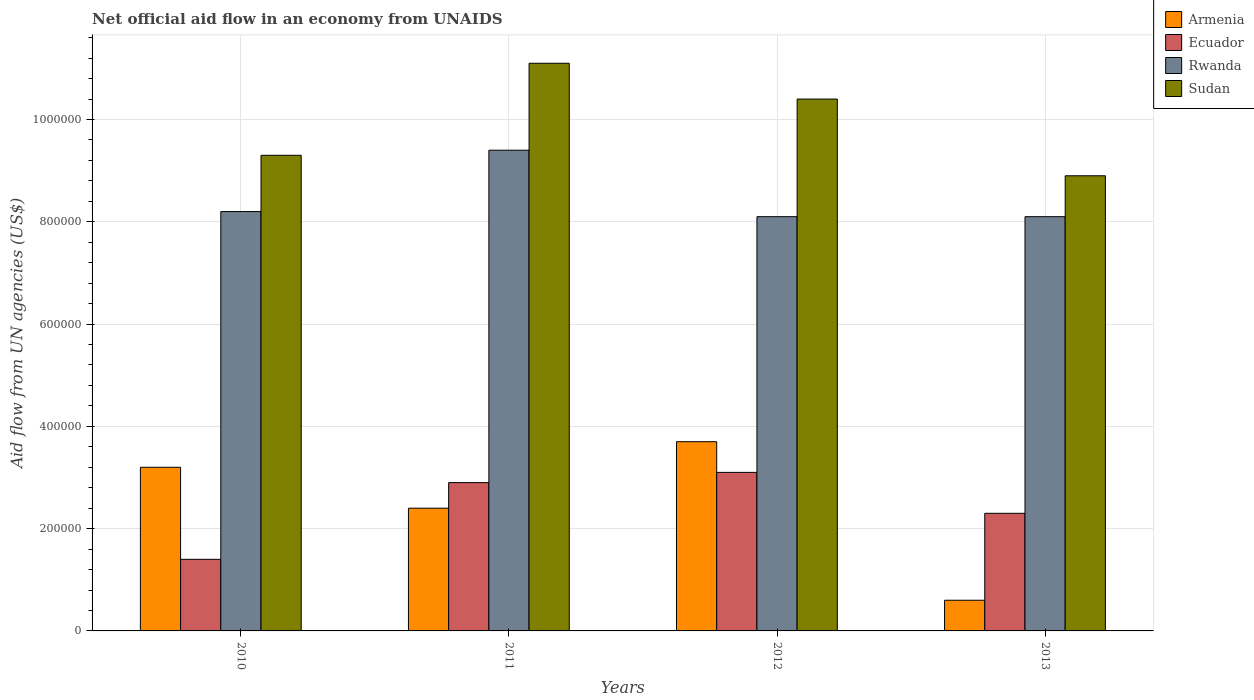Are the number of bars on each tick of the X-axis equal?
Provide a succinct answer. Yes. How many bars are there on the 1st tick from the left?
Your answer should be very brief. 4. How many bars are there on the 2nd tick from the right?
Provide a short and direct response. 4. In how many cases, is the number of bars for a given year not equal to the number of legend labels?
Give a very brief answer. 0. What is the net official aid flow in Sudan in 2012?
Offer a terse response. 1.04e+06. Across all years, what is the minimum net official aid flow in Rwanda?
Ensure brevity in your answer.  8.10e+05. In which year was the net official aid flow in Ecuador maximum?
Keep it short and to the point. 2012. What is the total net official aid flow in Ecuador in the graph?
Provide a succinct answer. 9.70e+05. What is the difference between the net official aid flow in Armenia in 2012 and that in 2013?
Keep it short and to the point. 3.10e+05. What is the average net official aid flow in Ecuador per year?
Offer a terse response. 2.42e+05. In the year 2010, what is the difference between the net official aid flow in Ecuador and net official aid flow in Rwanda?
Your answer should be compact. -6.80e+05. In how many years, is the net official aid flow in Armenia greater than 520000 US$?
Make the answer very short. 0. What is the ratio of the net official aid flow in Armenia in 2010 to that in 2011?
Your response must be concise. 1.33. Is the net official aid flow in Armenia in 2011 less than that in 2013?
Provide a succinct answer. No. Is the difference between the net official aid flow in Ecuador in 2011 and 2013 greater than the difference between the net official aid flow in Rwanda in 2011 and 2013?
Your response must be concise. No. What is the difference between the highest and the second highest net official aid flow in Rwanda?
Your response must be concise. 1.20e+05. What is the difference between the highest and the lowest net official aid flow in Armenia?
Keep it short and to the point. 3.10e+05. Is the sum of the net official aid flow in Rwanda in 2010 and 2011 greater than the maximum net official aid flow in Ecuador across all years?
Keep it short and to the point. Yes. Is it the case that in every year, the sum of the net official aid flow in Armenia and net official aid flow in Ecuador is greater than the sum of net official aid flow in Rwanda and net official aid flow in Sudan?
Provide a short and direct response. No. What does the 4th bar from the left in 2010 represents?
Your response must be concise. Sudan. What does the 1st bar from the right in 2013 represents?
Offer a very short reply. Sudan. Is it the case that in every year, the sum of the net official aid flow in Armenia and net official aid flow in Ecuador is greater than the net official aid flow in Sudan?
Ensure brevity in your answer.  No. Are the values on the major ticks of Y-axis written in scientific E-notation?
Provide a short and direct response. No. Does the graph contain any zero values?
Keep it short and to the point. No. Does the graph contain grids?
Offer a terse response. Yes. How many legend labels are there?
Your answer should be very brief. 4. How are the legend labels stacked?
Give a very brief answer. Vertical. What is the title of the graph?
Your answer should be very brief. Net official aid flow in an economy from UNAIDS. What is the label or title of the Y-axis?
Your answer should be very brief. Aid flow from UN agencies (US$). What is the Aid flow from UN agencies (US$) of Armenia in 2010?
Keep it short and to the point. 3.20e+05. What is the Aid flow from UN agencies (US$) in Rwanda in 2010?
Ensure brevity in your answer.  8.20e+05. What is the Aid flow from UN agencies (US$) of Sudan in 2010?
Offer a very short reply. 9.30e+05. What is the Aid flow from UN agencies (US$) of Ecuador in 2011?
Keep it short and to the point. 2.90e+05. What is the Aid flow from UN agencies (US$) in Rwanda in 2011?
Your answer should be compact. 9.40e+05. What is the Aid flow from UN agencies (US$) of Sudan in 2011?
Provide a short and direct response. 1.11e+06. What is the Aid flow from UN agencies (US$) of Armenia in 2012?
Keep it short and to the point. 3.70e+05. What is the Aid flow from UN agencies (US$) in Rwanda in 2012?
Make the answer very short. 8.10e+05. What is the Aid flow from UN agencies (US$) of Sudan in 2012?
Your answer should be compact. 1.04e+06. What is the Aid flow from UN agencies (US$) in Rwanda in 2013?
Your response must be concise. 8.10e+05. What is the Aid flow from UN agencies (US$) of Sudan in 2013?
Make the answer very short. 8.90e+05. Across all years, what is the maximum Aid flow from UN agencies (US$) of Ecuador?
Make the answer very short. 3.10e+05. Across all years, what is the maximum Aid flow from UN agencies (US$) in Rwanda?
Keep it short and to the point. 9.40e+05. Across all years, what is the maximum Aid flow from UN agencies (US$) in Sudan?
Make the answer very short. 1.11e+06. Across all years, what is the minimum Aid flow from UN agencies (US$) of Armenia?
Keep it short and to the point. 6.00e+04. Across all years, what is the minimum Aid flow from UN agencies (US$) in Rwanda?
Your response must be concise. 8.10e+05. Across all years, what is the minimum Aid flow from UN agencies (US$) of Sudan?
Offer a very short reply. 8.90e+05. What is the total Aid flow from UN agencies (US$) in Armenia in the graph?
Offer a terse response. 9.90e+05. What is the total Aid flow from UN agencies (US$) of Ecuador in the graph?
Provide a short and direct response. 9.70e+05. What is the total Aid flow from UN agencies (US$) of Rwanda in the graph?
Offer a terse response. 3.38e+06. What is the total Aid flow from UN agencies (US$) of Sudan in the graph?
Provide a succinct answer. 3.97e+06. What is the difference between the Aid flow from UN agencies (US$) in Armenia in 2010 and that in 2011?
Your answer should be compact. 8.00e+04. What is the difference between the Aid flow from UN agencies (US$) of Rwanda in 2010 and that in 2011?
Offer a terse response. -1.20e+05. What is the difference between the Aid flow from UN agencies (US$) of Armenia in 2010 and that in 2012?
Your answer should be very brief. -5.00e+04. What is the difference between the Aid flow from UN agencies (US$) in Sudan in 2010 and that in 2012?
Your answer should be very brief. -1.10e+05. What is the difference between the Aid flow from UN agencies (US$) in Ecuador in 2010 and that in 2013?
Give a very brief answer. -9.00e+04. What is the difference between the Aid flow from UN agencies (US$) of Rwanda in 2010 and that in 2013?
Give a very brief answer. 10000. What is the difference between the Aid flow from UN agencies (US$) in Sudan in 2010 and that in 2013?
Your answer should be very brief. 4.00e+04. What is the difference between the Aid flow from UN agencies (US$) of Armenia in 2011 and that in 2012?
Make the answer very short. -1.30e+05. What is the difference between the Aid flow from UN agencies (US$) of Sudan in 2011 and that in 2012?
Give a very brief answer. 7.00e+04. What is the difference between the Aid flow from UN agencies (US$) in Ecuador in 2011 and that in 2013?
Your answer should be compact. 6.00e+04. What is the difference between the Aid flow from UN agencies (US$) in Sudan in 2011 and that in 2013?
Offer a very short reply. 2.20e+05. What is the difference between the Aid flow from UN agencies (US$) of Armenia in 2010 and the Aid flow from UN agencies (US$) of Ecuador in 2011?
Make the answer very short. 3.00e+04. What is the difference between the Aid flow from UN agencies (US$) in Armenia in 2010 and the Aid flow from UN agencies (US$) in Rwanda in 2011?
Provide a succinct answer. -6.20e+05. What is the difference between the Aid flow from UN agencies (US$) in Armenia in 2010 and the Aid flow from UN agencies (US$) in Sudan in 2011?
Ensure brevity in your answer.  -7.90e+05. What is the difference between the Aid flow from UN agencies (US$) of Ecuador in 2010 and the Aid flow from UN agencies (US$) of Rwanda in 2011?
Offer a terse response. -8.00e+05. What is the difference between the Aid flow from UN agencies (US$) of Ecuador in 2010 and the Aid flow from UN agencies (US$) of Sudan in 2011?
Keep it short and to the point. -9.70e+05. What is the difference between the Aid flow from UN agencies (US$) in Armenia in 2010 and the Aid flow from UN agencies (US$) in Ecuador in 2012?
Provide a succinct answer. 10000. What is the difference between the Aid flow from UN agencies (US$) of Armenia in 2010 and the Aid flow from UN agencies (US$) of Rwanda in 2012?
Provide a short and direct response. -4.90e+05. What is the difference between the Aid flow from UN agencies (US$) of Armenia in 2010 and the Aid flow from UN agencies (US$) of Sudan in 2012?
Your answer should be compact. -7.20e+05. What is the difference between the Aid flow from UN agencies (US$) of Ecuador in 2010 and the Aid flow from UN agencies (US$) of Rwanda in 2012?
Your response must be concise. -6.70e+05. What is the difference between the Aid flow from UN agencies (US$) in Ecuador in 2010 and the Aid flow from UN agencies (US$) in Sudan in 2012?
Your response must be concise. -9.00e+05. What is the difference between the Aid flow from UN agencies (US$) of Rwanda in 2010 and the Aid flow from UN agencies (US$) of Sudan in 2012?
Keep it short and to the point. -2.20e+05. What is the difference between the Aid flow from UN agencies (US$) of Armenia in 2010 and the Aid flow from UN agencies (US$) of Ecuador in 2013?
Provide a succinct answer. 9.00e+04. What is the difference between the Aid flow from UN agencies (US$) of Armenia in 2010 and the Aid flow from UN agencies (US$) of Rwanda in 2013?
Your response must be concise. -4.90e+05. What is the difference between the Aid flow from UN agencies (US$) of Armenia in 2010 and the Aid flow from UN agencies (US$) of Sudan in 2013?
Keep it short and to the point. -5.70e+05. What is the difference between the Aid flow from UN agencies (US$) in Ecuador in 2010 and the Aid flow from UN agencies (US$) in Rwanda in 2013?
Provide a succinct answer. -6.70e+05. What is the difference between the Aid flow from UN agencies (US$) in Ecuador in 2010 and the Aid flow from UN agencies (US$) in Sudan in 2013?
Your answer should be very brief. -7.50e+05. What is the difference between the Aid flow from UN agencies (US$) in Armenia in 2011 and the Aid flow from UN agencies (US$) in Rwanda in 2012?
Your answer should be compact. -5.70e+05. What is the difference between the Aid flow from UN agencies (US$) in Armenia in 2011 and the Aid flow from UN agencies (US$) in Sudan in 2012?
Ensure brevity in your answer.  -8.00e+05. What is the difference between the Aid flow from UN agencies (US$) of Ecuador in 2011 and the Aid flow from UN agencies (US$) of Rwanda in 2012?
Give a very brief answer. -5.20e+05. What is the difference between the Aid flow from UN agencies (US$) in Ecuador in 2011 and the Aid flow from UN agencies (US$) in Sudan in 2012?
Keep it short and to the point. -7.50e+05. What is the difference between the Aid flow from UN agencies (US$) in Armenia in 2011 and the Aid flow from UN agencies (US$) in Rwanda in 2013?
Provide a short and direct response. -5.70e+05. What is the difference between the Aid flow from UN agencies (US$) of Armenia in 2011 and the Aid flow from UN agencies (US$) of Sudan in 2013?
Ensure brevity in your answer.  -6.50e+05. What is the difference between the Aid flow from UN agencies (US$) in Ecuador in 2011 and the Aid flow from UN agencies (US$) in Rwanda in 2013?
Your response must be concise. -5.20e+05. What is the difference between the Aid flow from UN agencies (US$) in Ecuador in 2011 and the Aid flow from UN agencies (US$) in Sudan in 2013?
Ensure brevity in your answer.  -6.00e+05. What is the difference between the Aid flow from UN agencies (US$) of Armenia in 2012 and the Aid flow from UN agencies (US$) of Rwanda in 2013?
Make the answer very short. -4.40e+05. What is the difference between the Aid flow from UN agencies (US$) in Armenia in 2012 and the Aid flow from UN agencies (US$) in Sudan in 2013?
Your answer should be compact. -5.20e+05. What is the difference between the Aid flow from UN agencies (US$) in Ecuador in 2012 and the Aid flow from UN agencies (US$) in Rwanda in 2013?
Your answer should be compact. -5.00e+05. What is the difference between the Aid flow from UN agencies (US$) of Ecuador in 2012 and the Aid flow from UN agencies (US$) of Sudan in 2013?
Your response must be concise. -5.80e+05. What is the average Aid flow from UN agencies (US$) in Armenia per year?
Provide a succinct answer. 2.48e+05. What is the average Aid flow from UN agencies (US$) in Ecuador per year?
Offer a terse response. 2.42e+05. What is the average Aid flow from UN agencies (US$) in Rwanda per year?
Provide a succinct answer. 8.45e+05. What is the average Aid flow from UN agencies (US$) in Sudan per year?
Your answer should be compact. 9.92e+05. In the year 2010, what is the difference between the Aid flow from UN agencies (US$) of Armenia and Aid flow from UN agencies (US$) of Rwanda?
Your answer should be very brief. -5.00e+05. In the year 2010, what is the difference between the Aid flow from UN agencies (US$) of Armenia and Aid flow from UN agencies (US$) of Sudan?
Your answer should be compact. -6.10e+05. In the year 2010, what is the difference between the Aid flow from UN agencies (US$) of Ecuador and Aid flow from UN agencies (US$) of Rwanda?
Your answer should be very brief. -6.80e+05. In the year 2010, what is the difference between the Aid flow from UN agencies (US$) of Ecuador and Aid flow from UN agencies (US$) of Sudan?
Offer a very short reply. -7.90e+05. In the year 2010, what is the difference between the Aid flow from UN agencies (US$) in Rwanda and Aid flow from UN agencies (US$) in Sudan?
Provide a short and direct response. -1.10e+05. In the year 2011, what is the difference between the Aid flow from UN agencies (US$) of Armenia and Aid flow from UN agencies (US$) of Ecuador?
Your response must be concise. -5.00e+04. In the year 2011, what is the difference between the Aid flow from UN agencies (US$) of Armenia and Aid flow from UN agencies (US$) of Rwanda?
Provide a short and direct response. -7.00e+05. In the year 2011, what is the difference between the Aid flow from UN agencies (US$) of Armenia and Aid flow from UN agencies (US$) of Sudan?
Provide a short and direct response. -8.70e+05. In the year 2011, what is the difference between the Aid flow from UN agencies (US$) in Ecuador and Aid flow from UN agencies (US$) in Rwanda?
Provide a succinct answer. -6.50e+05. In the year 2011, what is the difference between the Aid flow from UN agencies (US$) of Ecuador and Aid flow from UN agencies (US$) of Sudan?
Your answer should be very brief. -8.20e+05. In the year 2012, what is the difference between the Aid flow from UN agencies (US$) of Armenia and Aid flow from UN agencies (US$) of Ecuador?
Provide a succinct answer. 6.00e+04. In the year 2012, what is the difference between the Aid flow from UN agencies (US$) of Armenia and Aid flow from UN agencies (US$) of Rwanda?
Ensure brevity in your answer.  -4.40e+05. In the year 2012, what is the difference between the Aid flow from UN agencies (US$) of Armenia and Aid flow from UN agencies (US$) of Sudan?
Offer a very short reply. -6.70e+05. In the year 2012, what is the difference between the Aid flow from UN agencies (US$) of Ecuador and Aid flow from UN agencies (US$) of Rwanda?
Keep it short and to the point. -5.00e+05. In the year 2012, what is the difference between the Aid flow from UN agencies (US$) of Ecuador and Aid flow from UN agencies (US$) of Sudan?
Ensure brevity in your answer.  -7.30e+05. In the year 2013, what is the difference between the Aid flow from UN agencies (US$) of Armenia and Aid flow from UN agencies (US$) of Ecuador?
Make the answer very short. -1.70e+05. In the year 2013, what is the difference between the Aid flow from UN agencies (US$) of Armenia and Aid flow from UN agencies (US$) of Rwanda?
Offer a very short reply. -7.50e+05. In the year 2013, what is the difference between the Aid flow from UN agencies (US$) of Armenia and Aid flow from UN agencies (US$) of Sudan?
Ensure brevity in your answer.  -8.30e+05. In the year 2013, what is the difference between the Aid flow from UN agencies (US$) in Ecuador and Aid flow from UN agencies (US$) in Rwanda?
Your answer should be compact. -5.80e+05. In the year 2013, what is the difference between the Aid flow from UN agencies (US$) of Ecuador and Aid flow from UN agencies (US$) of Sudan?
Provide a succinct answer. -6.60e+05. In the year 2013, what is the difference between the Aid flow from UN agencies (US$) in Rwanda and Aid flow from UN agencies (US$) in Sudan?
Make the answer very short. -8.00e+04. What is the ratio of the Aid flow from UN agencies (US$) of Ecuador in 2010 to that in 2011?
Offer a terse response. 0.48. What is the ratio of the Aid flow from UN agencies (US$) in Rwanda in 2010 to that in 2011?
Your answer should be compact. 0.87. What is the ratio of the Aid flow from UN agencies (US$) of Sudan in 2010 to that in 2011?
Your answer should be compact. 0.84. What is the ratio of the Aid flow from UN agencies (US$) of Armenia in 2010 to that in 2012?
Provide a succinct answer. 0.86. What is the ratio of the Aid flow from UN agencies (US$) in Ecuador in 2010 to that in 2012?
Your answer should be very brief. 0.45. What is the ratio of the Aid flow from UN agencies (US$) of Rwanda in 2010 to that in 2012?
Your answer should be very brief. 1.01. What is the ratio of the Aid flow from UN agencies (US$) of Sudan in 2010 to that in 2012?
Give a very brief answer. 0.89. What is the ratio of the Aid flow from UN agencies (US$) in Armenia in 2010 to that in 2013?
Make the answer very short. 5.33. What is the ratio of the Aid flow from UN agencies (US$) in Ecuador in 2010 to that in 2013?
Provide a short and direct response. 0.61. What is the ratio of the Aid flow from UN agencies (US$) in Rwanda in 2010 to that in 2013?
Offer a terse response. 1.01. What is the ratio of the Aid flow from UN agencies (US$) in Sudan in 2010 to that in 2013?
Your answer should be very brief. 1.04. What is the ratio of the Aid flow from UN agencies (US$) of Armenia in 2011 to that in 2012?
Give a very brief answer. 0.65. What is the ratio of the Aid flow from UN agencies (US$) in Ecuador in 2011 to that in 2012?
Offer a terse response. 0.94. What is the ratio of the Aid flow from UN agencies (US$) in Rwanda in 2011 to that in 2012?
Offer a very short reply. 1.16. What is the ratio of the Aid flow from UN agencies (US$) in Sudan in 2011 to that in 2012?
Your answer should be very brief. 1.07. What is the ratio of the Aid flow from UN agencies (US$) in Armenia in 2011 to that in 2013?
Provide a succinct answer. 4. What is the ratio of the Aid flow from UN agencies (US$) in Ecuador in 2011 to that in 2013?
Your response must be concise. 1.26. What is the ratio of the Aid flow from UN agencies (US$) in Rwanda in 2011 to that in 2013?
Offer a very short reply. 1.16. What is the ratio of the Aid flow from UN agencies (US$) of Sudan in 2011 to that in 2013?
Keep it short and to the point. 1.25. What is the ratio of the Aid flow from UN agencies (US$) of Armenia in 2012 to that in 2013?
Provide a succinct answer. 6.17. What is the ratio of the Aid flow from UN agencies (US$) of Ecuador in 2012 to that in 2013?
Make the answer very short. 1.35. What is the ratio of the Aid flow from UN agencies (US$) in Rwanda in 2012 to that in 2013?
Provide a short and direct response. 1. What is the ratio of the Aid flow from UN agencies (US$) in Sudan in 2012 to that in 2013?
Offer a terse response. 1.17. What is the difference between the highest and the second highest Aid flow from UN agencies (US$) in Ecuador?
Ensure brevity in your answer.  2.00e+04. What is the difference between the highest and the second highest Aid flow from UN agencies (US$) of Sudan?
Your answer should be very brief. 7.00e+04. What is the difference between the highest and the lowest Aid flow from UN agencies (US$) of Rwanda?
Your response must be concise. 1.30e+05. 